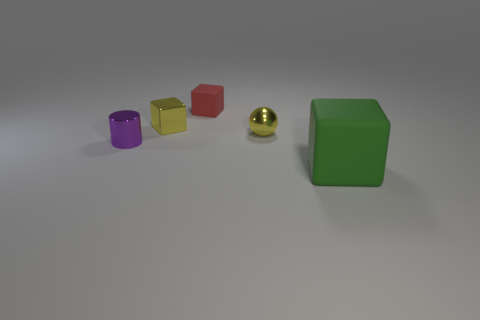Add 5 purple metallic cylinders. How many objects exist? 10 Subtract all cylinders. How many objects are left? 4 Subtract 1 green blocks. How many objects are left? 4 Subtract all purple metallic cylinders. Subtract all rubber things. How many objects are left? 2 Add 1 small red blocks. How many small red blocks are left? 2 Add 4 small purple objects. How many small purple objects exist? 5 